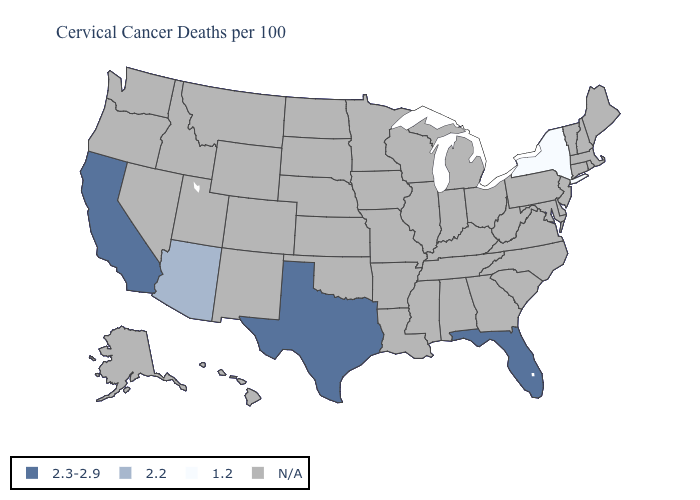What is the value of Alabama?
Keep it brief. N/A. What is the value of Arizona?
Give a very brief answer. 2.2. Name the states that have a value in the range 1.2?
Answer briefly. New York. What is the lowest value in states that border Utah?
Short answer required. 2.2. Does the first symbol in the legend represent the smallest category?
Keep it brief. No. What is the value of Vermont?
Give a very brief answer. N/A. Name the states that have a value in the range N/A?
Give a very brief answer. Alabama, Alaska, Arkansas, Colorado, Connecticut, Delaware, Georgia, Hawaii, Idaho, Illinois, Indiana, Iowa, Kansas, Kentucky, Louisiana, Maine, Maryland, Massachusetts, Michigan, Minnesota, Mississippi, Missouri, Montana, Nebraska, Nevada, New Hampshire, New Jersey, New Mexico, North Carolina, North Dakota, Ohio, Oklahoma, Oregon, Pennsylvania, Rhode Island, South Carolina, South Dakota, Tennessee, Utah, Vermont, Virginia, Washington, West Virginia, Wisconsin, Wyoming. How many symbols are there in the legend?
Keep it brief. 4. Does Arizona have the highest value in the USA?
Write a very short answer. No. Does Florida have the lowest value in the USA?
Give a very brief answer. No. Which states have the lowest value in the Northeast?
Concise answer only. New York. 